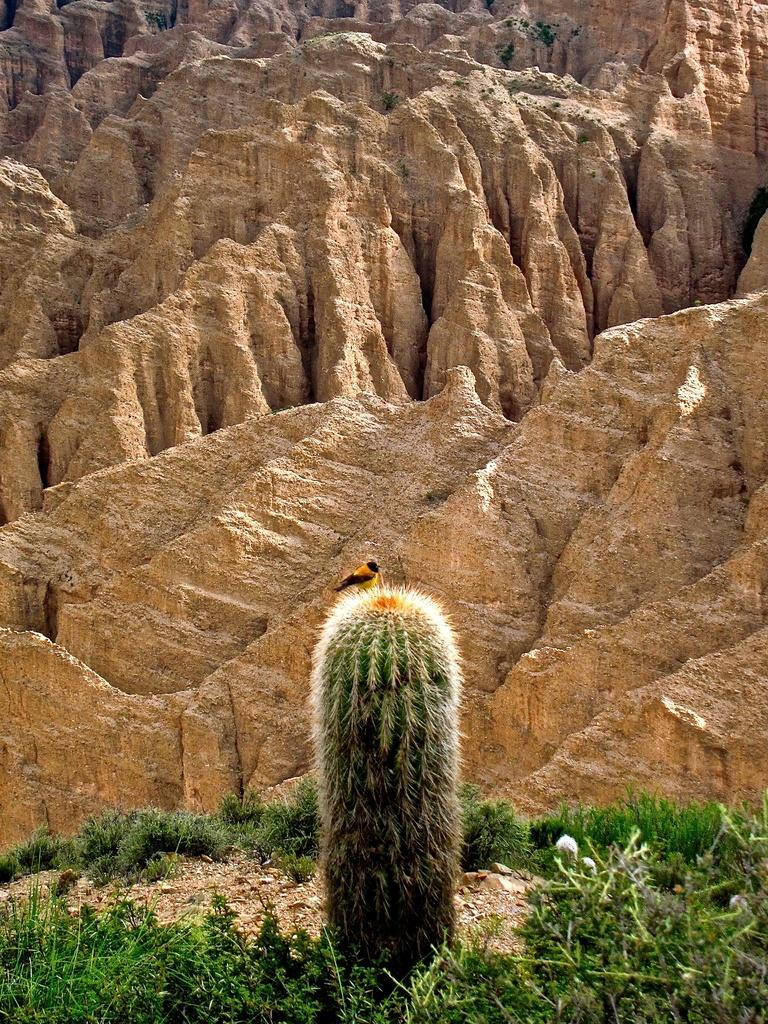What type of plant can be seen in the image? There is a cactus in the image. What other type of vegetation is present in the image? There is grass in the image. Are there any other plants visible in the image? Yes, there are plants in the image. What can be seen in the background of the image? There are stones visible in the background of the image. What type of animal is present in the image? There is a bird in the image. Can you tell me how many eyes the scarecrow has in the image? There is no scarecrow present in the image, so it is not possible to determine the number of eyes it might have. 